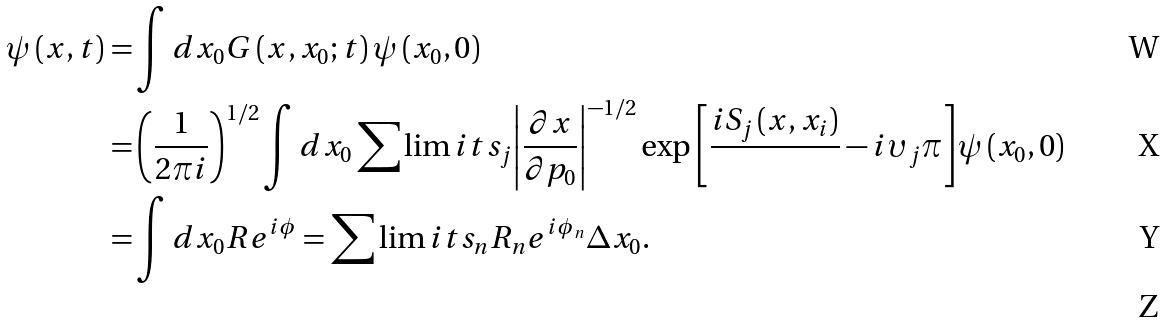Convert formula to latex. <formula><loc_0><loc_0><loc_500><loc_500>\psi \left ( { x , t } \right ) = & \int { d x _ { 0 } G \left ( { x , x _ { 0 } ; t } \right ) \psi \left ( { x _ { 0 } , 0 } \right ) } \\ = & \left ( { \frac { 1 } { 2 \pi i } } \right ) ^ { 1 / 2 } \int { d x _ { 0 } \sum \lim i t s _ { j } { \left | { \frac { \partial x } { \partial p _ { 0 } } } \right | ^ { - 1 / 2 } \exp \left [ { \frac { { i S _ { j } \left ( { x , x _ { i } } \right ) } } { } - i \upsilon _ { j } \pi } \right ] } } \psi \left ( { x _ { 0 } , 0 } \right ) \\ = & \int { d x _ { 0 } R e ^ { i \phi } } = \sum \lim i t s _ { n } { R _ { n } e ^ { i \phi _ { n } } \Delta x _ { 0 } } . \\</formula> 